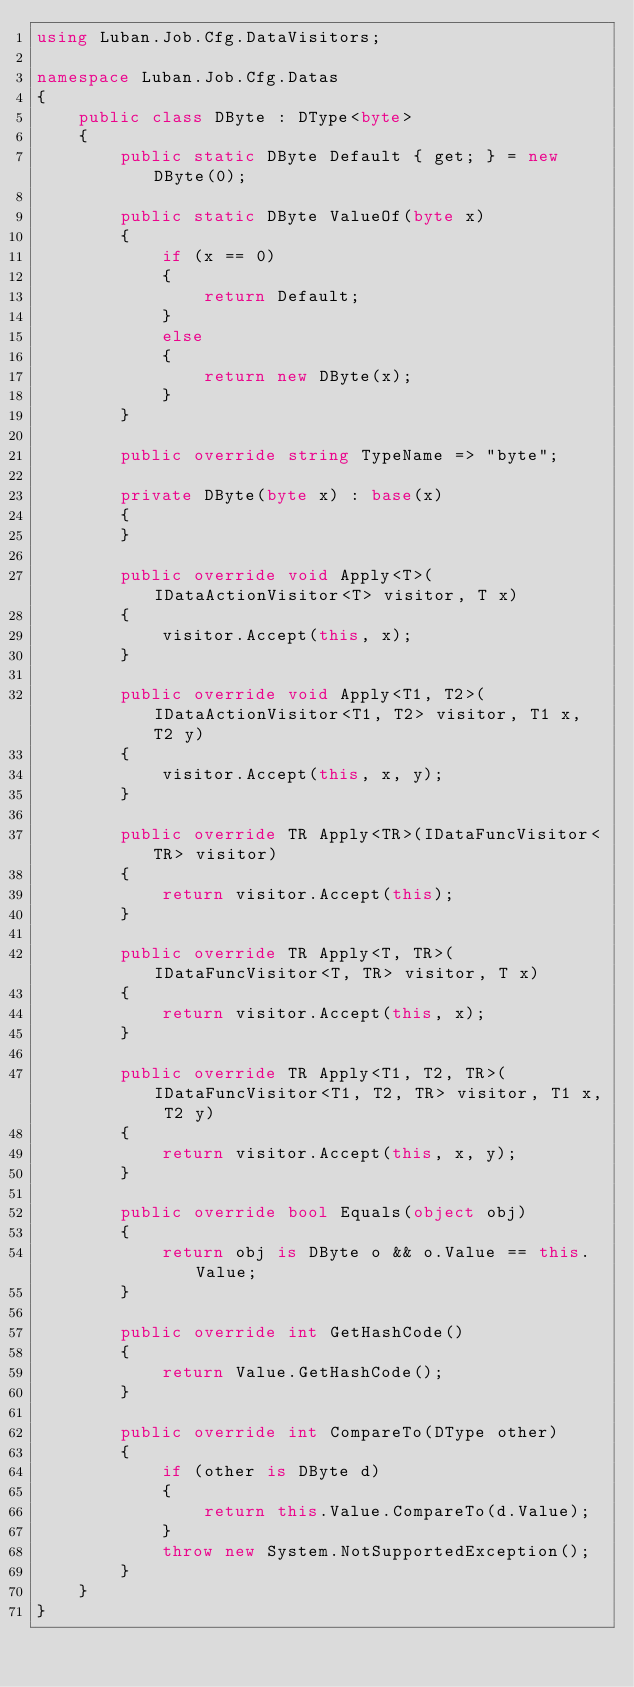Convert code to text. <code><loc_0><loc_0><loc_500><loc_500><_C#_>using Luban.Job.Cfg.DataVisitors;

namespace Luban.Job.Cfg.Datas
{
    public class DByte : DType<byte>
    {
        public static DByte Default { get; } = new DByte(0);

        public static DByte ValueOf(byte x)
        {
            if (x == 0)
            {
                return Default;
            }
            else
            {
                return new DByte(x);
            }
        }

        public override string TypeName => "byte";

        private DByte(byte x) : base(x)
        {
        }

        public override void Apply<T>(IDataActionVisitor<T> visitor, T x)
        {
            visitor.Accept(this, x);
        }

        public override void Apply<T1, T2>(IDataActionVisitor<T1, T2> visitor, T1 x, T2 y)
        {
            visitor.Accept(this, x, y);
        }

        public override TR Apply<TR>(IDataFuncVisitor<TR> visitor)
        {
            return visitor.Accept(this);
        }

        public override TR Apply<T, TR>(IDataFuncVisitor<T, TR> visitor, T x)
        {
            return visitor.Accept(this, x);
        }

        public override TR Apply<T1, T2, TR>(IDataFuncVisitor<T1, T2, TR> visitor, T1 x, T2 y)
        {
            return visitor.Accept(this, x, y);
        }

        public override bool Equals(object obj)
        {
            return obj is DByte o && o.Value == this.Value;
        }

        public override int GetHashCode()
        {
            return Value.GetHashCode();
        }

        public override int CompareTo(DType other)
        {
            if (other is DByte d)
            {
                return this.Value.CompareTo(d.Value);
            }
            throw new System.NotSupportedException();
        }
    }
}
</code> 